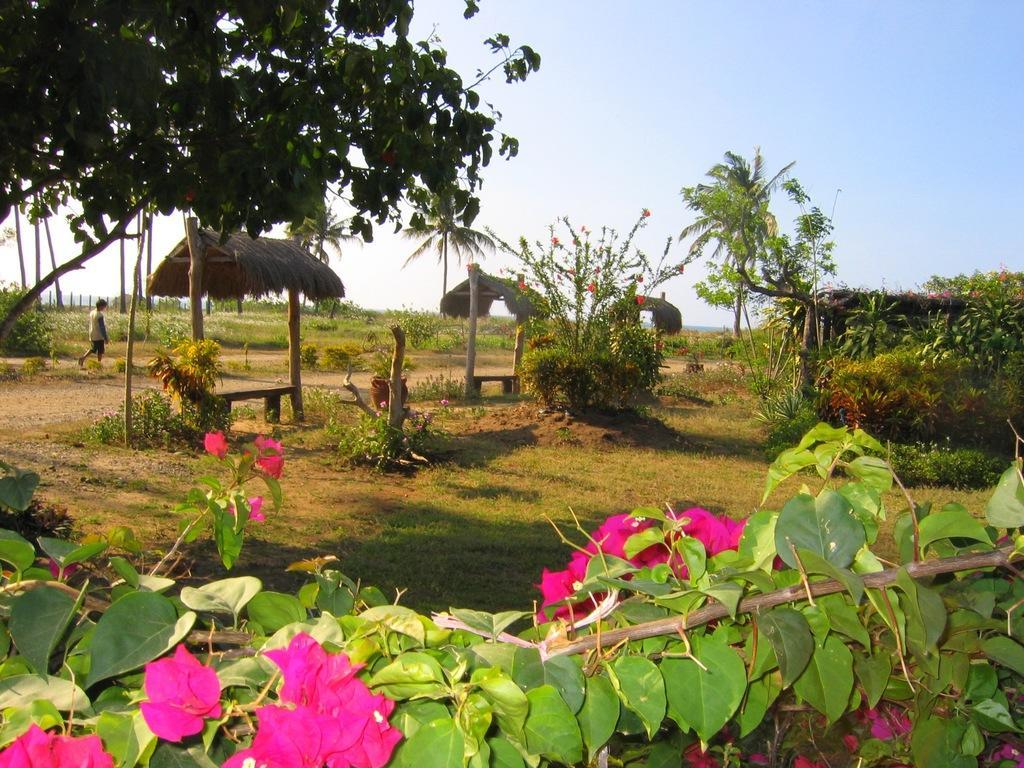Could you give a brief overview of what you see in this image? In this image there are plants in the front. In the center there are tents and there's grass on the ground. In the background there is a person walking. On the left side in the front there is a tree. On the right side there are trees and in the background there is a fence. 